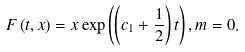<formula> <loc_0><loc_0><loc_500><loc_500>F \left ( t , x \right ) = x \exp \left ( \left ( c _ { 1 } + \frac { 1 } { 2 } \right ) t \right ) , m = 0 .</formula> 